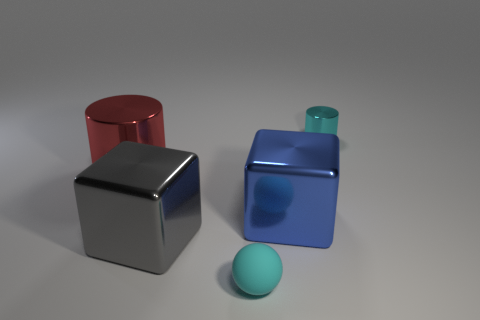Add 5 large blue cubes. How many objects exist? 10 Subtract all balls. How many objects are left? 4 Subtract all small gray objects. Subtract all big cylinders. How many objects are left? 4 Add 2 big metallic cubes. How many big metallic cubes are left? 4 Add 5 big objects. How many big objects exist? 8 Subtract 1 blue cubes. How many objects are left? 4 